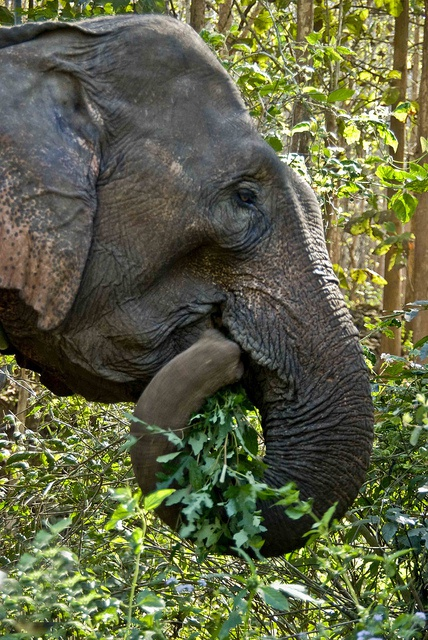Describe the objects in this image and their specific colors. I can see a elephant in khaki, gray, black, darkgreen, and darkgray tones in this image. 